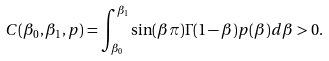<formula> <loc_0><loc_0><loc_500><loc_500>C ( \beta _ { 0 } , \beta _ { 1 } , p ) = \int _ { \beta _ { 0 } } ^ { \beta _ { 1 } } \sin ( \beta \pi ) \Gamma ( 1 - \beta ) p ( \beta ) d \beta > 0 .</formula> 